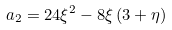Convert formula to latex. <formula><loc_0><loc_0><loc_500><loc_500>a _ { 2 } = 2 4 \xi ^ { 2 } - 8 \xi \left ( 3 + \eta \right )</formula> 